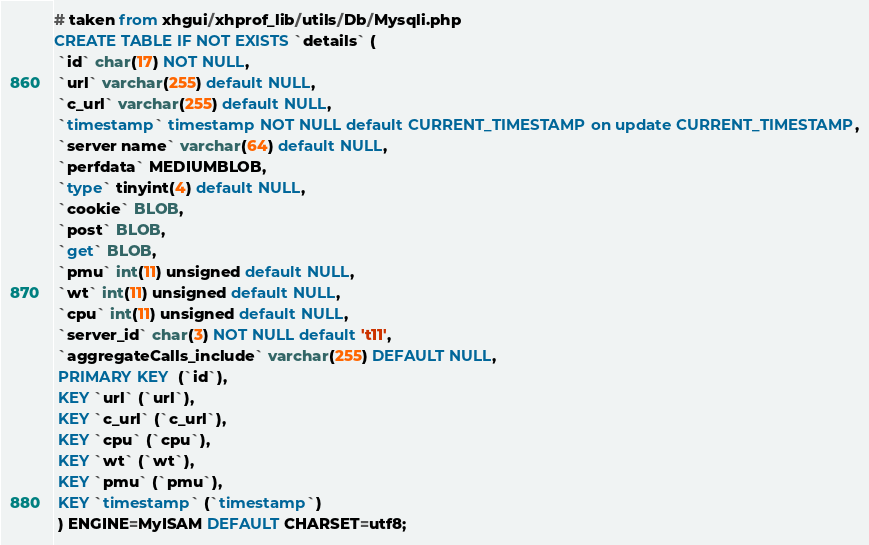Convert code to text. <code><loc_0><loc_0><loc_500><loc_500><_SQL_># taken from xhgui/xhprof_lib/utils/Db/Mysqli.php
CREATE TABLE IF NOT EXISTS `details` (
 `id` char(17) NOT NULL,
 `url` varchar(255) default NULL,
 `c_url` varchar(255) default NULL,
 `timestamp` timestamp NOT NULL default CURRENT_TIMESTAMP on update CURRENT_TIMESTAMP,
 `server name` varchar(64) default NULL,
 `perfdata` MEDIUMBLOB,
 `type` tinyint(4) default NULL,
 `cookie` BLOB,
 `post` BLOB,
 `get` BLOB,
 `pmu` int(11) unsigned default NULL,
 `wt` int(11) unsigned default NULL,
 `cpu` int(11) unsigned default NULL,
 `server_id` char(3) NOT NULL default 't11',
 `aggregateCalls_include` varchar(255) DEFAULT NULL,
 PRIMARY KEY  (`id`),
 KEY `url` (`url`),
 KEY `c_url` (`c_url`),
 KEY `cpu` (`cpu`),
 KEY `wt` (`wt`),
 KEY `pmu` (`pmu`),
 KEY `timestamp` (`timestamp`)
 ) ENGINE=MyISAM DEFAULT CHARSET=utf8;
</code> 